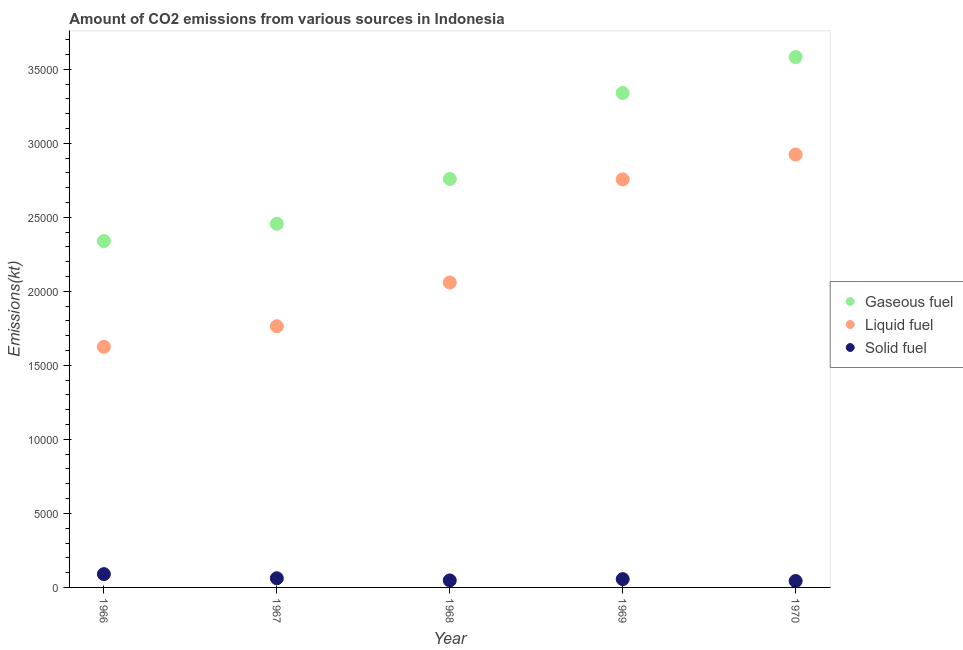How many different coloured dotlines are there?
Your answer should be very brief. 3. Is the number of dotlines equal to the number of legend labels?
Offer a terse response. Yes. What is the amount of co2 emissions from liquid fuel in 1969?
Make the answer very short. 2.76e+04. Across all years, what is the maximum amount of co2 emissions from solid fuel?
Offer a terse response. 898.41. Across all years, what is the minimum amount of co2 emissions from liquid fuel?
Your answer should be compact. 1.63e+04. In which year was the amount of co2 emissions from solid fuel maximum?
Ensure brevity in your answer.  1966. In which year was the amount of co2 emissions from gaseous fuel minimum?
Provide a succinct answer. 1966. What is the total amount of co2 emissions from liquid fuel in the graph?
Give a very brief answer. 1.11e+05. What is the difference between the amount of co2 emissions from solid fuel in 1969 and that in 1970?
Your answer should be compact. 128.34. What is the difference between the amount of co2 emissions from solid fuel in 1969 and the amount of co2 emissions from gaseous fuel in 1967?
Provide a short and direct response. -2.40e+04. What is the average amount of co2 emissions from gaseous fuel per year?
Provide a succinct answer. 2.90e+04. In the year 1967, what is the difference between the amount of co2 emissions from solid fuel and amount of co2 emissions from liquid fuel?
Your answer should be compact. -1.70e+04. In how many years, is the amount of co2 emissions from solid fuel greater than 4000 kt?
Keep it short and to the point. 0. What is the ratio of the amount of co2 emissions from solid fuel in 1967 to that in 1968?
Make the answer very short. 1.31. Is the amount of co2 emissions from gaseous fuel in 1966 less than that in 1970?
Your answer should be very brief. Yes. What is the difference between the highest and the second highest amount of co2 emissions from gaseous fuel?
Offer a very short reply. 2431.22. What is the difference between the highest and the lowest amount of co2 emissions from solid fuel?
Your answer should be compact. 465.71. Are the values on the major ticks of Y-axis written in scientific E-notation?
Ensure brevity in your answer.  No. Does the graph contain grids?
Keep it short and to the point. No. How many legend labels are there?
Keep it short and to the point. 3. How are the legend labels stacked?
Keep it short and to the point. Vertical. What is the title of the graph?
Ensure brevity in your answer.  Amount of CO2 emissions from various sources in Indonesia. Does "Coal" appear as one of the legend labels in the graph?
Your answer should be very brief. No. What is the label or title of the X-axis?
Keep it short and to the point. Year. What is the label or title of the Y-axis?
Ensure brevity in your answer.  Emissions(kt). What is the Emissions(kt) in Gaseous fuel in 1966?
Give a very brief answer. 2.34e+04. What is the Emissions(kt) of Liquid fuel in 1966?
Keep it short and to the point. 1.63e+04. What is the Emissions(kt) in Solid fuel in 1966?
Make the answer very short. 898.41. What is the Emissions(kt) in Gaseous fuel in 1967?
Your answer should be compact. 2.46e+04. What is the Emissions(kt) in Liquid fuel in 1967?
Offer a very short reply. 1.76e+04. What is the Emissions(kt) of Solid fuel in 1967?
Keep it short and to the point. 619.72. What is the Emissions(kt) of Gaseous fuel in 1968?
Keep it short and to the point. 2.76e+04. What is the Emissions(kt) in Liquid fuel in 1968?
Make the answer very short. 2.06e+04. What is the Emissions(kt) of Solid fuel in 1968?
Provide a short and direct response. 473.04. What is the Emissions(kt) of Gaseous fuel in 1969?
Your answer should be compact. 3.34e+04. What is the Emissions(kt) of Liquid fuel in 1969?
Your answer should be compact. 2.76e+04. What is the Emissions(kt) of Solid fuel in 1969?
Ensure brevity in your answer.  561.05. What is the Emissions(kt) in Gaseous fuel in 1970?
Give a very brief answer. 3.58e+04. What is the Emissions(kt) of Liquid fuel in 1970?
Your answer should be very brief. 2.92e+04. What is the Emissions(kt) in Solid fuel in 1970?
Provide a succinct answer. 432.71. Across all years, what is the maximum Emissions(kt) of Gaseous fuel?
Provide a short and direct response. 3.58e+04. Across all years, what is the maximum Emissions(kt) of Liquid fuel?
Offer a terse response. 2.92e+04. Across all years, what is the maximum Emissions(kt) of Solid fuel?
Keep it short and to the point. 898.41. Across all years, what is the minimum Emissions(kt) in Gaseous fuel?
Your answer should be very brief. 2.34e+04. Across all years, what is the minimum Emissions(kt) in Liquid fuel?
Make the answer very short. 1.63e+04. Across all years, what is the minimum Emissions(kt) in Solid fuel?
Make the answer very short. 432.71. What is the total Emissions(kt) of Gaseous fuel in the graph?
Make the answer very short. 1.45e+05. What is the total Emissions(kt) in Liquid fuel in the graph?
Offer a terse response. 1.11e+05. What is the total Emissions(kt) of Solid fuel in the graph?
Keep it short and to the point. 2984.94. What is the difference between the Emissions(kt) of Gaseous fuel in 1966 and that in 1967?
Your answer should be very brief. -1166.11. What is the difference between the Emissions(kt) in Liquid fuel in 1966 and that in 1967?
Offer a very short reply. -1386.13. What is the difference between the Emissions(kt) in Solid fuel in 1966 and that in 1967?
Provide a succinct answer. 278.69. What is the difference between the Emissions(kt) of Gaseous fuel in 1966 and that in 1968?
Your response must be concise. -4191.38. What is the difference between the Emissions(kt) in Liquid fuel in 1966 and that in 1968?
Your response must be concise. -4341.73. What is the difference between the Emissions(kt) of Solid fuel in 1966 and that in 1968?
Offer a terse response. 425.37. What is the difference between the Emissions(kt) of Gaseous fuel in 1966 and that in 1969?
Provide a succinct answer. -9996.24. What is the difference between the Emissions(kt) in Liquid fuel in 1966 and that in 1969?
Give a very brief answer. -1.13e+04. What is the difference between the Emissions(kt) of Solid fuel in 1966 and that in 1969?
Keep it short and to the point. 337.36. What is the difference between the Emissions(kt) in Gaseous fuel in 1966 and that in 1970?
Provide a succinct answer. -1.24e+04. What is the difference between the Emissions(kt) in Liquid fuel in 1966 and that in 1970?
Provide a short and direct response. -1.30e+04. What is the difference between the Emissions(kt) of Solid fuel in 1966 and that in 1970?
Your answer should be compact. 465.71. What is the difference between the Emissions(kt) of Gaseous fuel in 1967 and that in 1968?
Keep it short and to the point. -3025.28. What is the difference between the Emissions(kt) of Liquid fuel in 1967 and that in 1968?
Make the answer very short. -2955.6. What is the difference between the Emissions(kt) of Solid fuel in 1967 and that in 1968?
Your answer should be compact. 146.68. What is the difference between the Emissions(kt) of Gaseous fuel in 1967 and that in 1969?
Your answer should be very brief. -8830.14. What is the difference between the Emissions(kt) of Liquid fuel in 1967 and that in 1969?
Your response must be concise. -9919.24. What is the difference between the Emissions(kt) of Solid fuel in 1967 and that in 1969?
Offer a very short reply. 58.67. What is the difference between the Emissions(kt) in Gaseous fuel in 1967 and that in 1970?
Provide a short and direct response. -1.13e+04. What is the difference between the Emissions(kt) in Liquid fuel in 1967 and that in 1970?
Ensure brevity in your answer.  -1.16e+04. What is the difference between the Emissions(kt) in Solid fuel in 1967 and that in 1970?
Provide a short and direct response. 187.02. What is the difference between the Emissions(kt) in Gaseous fuel in 1968 and that in 1969?
Your answer should be very brief. -5804.86. What is the difference between the Emissions(kt) in Liquid fuel in 1968 and that in 1969?
Give a very brief answer. -6963.63. What is the difference between the Emissions(kt) of Solid fuel in 1968 and that in 1969?
Provide a succinct answer. -88.01. What is the difference between the Emissions(kt) in Gaseous fuel in 1968 and that in 1970?
Give a very brief answer. -8236.08. What is the difference between the Emissions(kt) in Liquid fuel in 1968 and that in 1970?
Provide a short and direct response. -8643.12. What is the difference between the Emissions(kt) in Solid fuel in 1968 and that in 1970?
Offer a terse response. 40.34. What is the difference between the Emissions(kt) of Gaseous fuel in 1969 and that in 1970?
Your answer should be very brief. -2431.22. What is the difference between the Emissions(kt) in Liquid fuel in 1969 and that in 1970?
Ensure brevity in your answer.  -1679.49. What is the difference between the Emissions(kt) of Solid fuel in 1969 and that in 1970?
Provide a succinct answer. 128.34. What is the difference between the Emissions(kt) in Gaseous fuel in 1966 and the Emissions(kt) in Liquid fuel in 1967?
Your response must be concise. 5757.19. What is the difference between the Emissions(kt) in Gaseous fuel in 1966 and the Emissions(kt) in Solid fuel in 1967?
Provide a short and direct response. 2.28e+04. What is the difference between the Emissions(kt) in Liquid fuel in 1966 and the Emissions(kt) in Solid fuel in 1967?
Ensure brevity in your answer.  1.56e+04. What is the difference between the Emissions(kt) of Gaseous fuel in 1966 and the Emissions(kt) of Liquid fuel in 1968?
Provide a succinct answer. 2801.59. What is the difference between the Emissions(kt) of Gaseous fuel in 1966 and the Emissions(kt) of Solid fuel in 1968?
Give a very brief answer. 2.29e+04. What is the difference between the Emissions(kt) of Liquid fuel in 1966 and the Emissions(kt) of Solid fuel in 1968?
Ensure brevity in your answer.  1.58e+04. What is the difference between the Emissions(kt) in Gaseous fuel in 1966 and the Emissions(kt) in Liquid fuel in 1969?
Your response must be concise. -4162.05. What is the difference between the Emissions(kt) of Gaseous fuel in 1966 and the Emissions(kt) of Solid fuel in 1969?
Make the answer very short. 2.28e+04. What is the difference between the Emissions(kt) of Liquid fuel in 1966 and the Emissions(kt) of Solid fuel in 1969?
Make the answer very short. 1.57e+04. What is the difference between the Emissions(kt) of Gaseous fuel in 1966 and the Emissions(kt) of Liquid fuel in 1970?
Make the answer very short. -5841.53. What is the difference between the Emissions(kt) of Gaseous fuel in 1966 and the Emissions(kt) of Solid fuel in 1970?
Your response must be concise. 2.30e+04. What is the difference between the Emissions(kt) in Liquid fuel in 1966 and the Emissions(kt) in Solid fuel in 1970?
Your answer should be compact. 1.58e+04. What is the difference between the Emissions(kt) of Gaseous fuel in 1967 and the Emissions(kt) of Liquid fuel in 1968?
Ensure brevity in your answer.  3967.69. What is the difference between the Emissions(kt) in Gaseous fuel in 1967 and the Emissions(kt) in Solid fuel in 1968?
Give a very brief answer. 2.41e+04. What is the difference between the Emissions(kt) of Liquid fuel in 1967 and the Emissions(kt) of Solid fuel in 1968?
Offer a terse response. 1.72e+04. What is the difference between the Emissions(kt) in Gaseous fuel in 1967 and the Emissions(kt) in Liquid fuel in 1969?
Ensure brevity in your answer.  -2995.94. What is the difference between the Emissions(kt) in Gaseous fuel in 1967 and the Emissions(kt) in Solid fuel in 1969?
Your answer should be very brief. 2.40e+04. What is the difference between the Emissions(kt) of Liquid fuel in 1967 and the Emissions(kt) of Solid fuel in 1969?
Make the answer very short. 1.71e+04. What is the difference between the Emissions(kt) of Gaseous fuel in 1967 and the Emissions(kt) of Liquid fuel in 1970?
Provide a short and direct response. -4675.43. What is the difference between the Emissions(kt) in Gaseous fuel in 1967 and the Emissions(kt) in Solid fuel in 1970?
Ensure brevity in your answer.  2.41e+04. What is the difference between the Emissions(kt) in Liquid fuel in 1967 and the Emissions(kt) in Solid fuel in 1970?
Your answer should be compact. 1.72e+04. What is the difference between the Emissions(kt) in Gaseous fuel in 1968 and the Emissions(kt) in Liquid fuel in 1969?
Give a very brief answer. 29.34. What is the difference between the Emissions(kt) in Gaseous fuel in 1968 and the Emissions(kt) in Solid fuel in 1969?
Make the answer very short. 2.70e+04. What is the difference between the Emissions(kt) of Liquid fuel in 1968 and the Emissions(kt) of Solid fuel in 1969?
Provide a short and direct response. 2.00e+04. What is the difference between the Emissions(kt) in Gaseous fuel in 1968 and the Emissions(kt) in Liquid fuel in 1970?
Keep it short and to the point. -1650.15. What is the difference between the Emissions(kt) in Gaseous fuel in 1968 and the Emissions(kt) in Solid fuel in 1970?
Your answer should be very brief. 2.72e+04. What is the difference between the Emissions(kt) in Liquid fuel in 1968 and the Emissions(kt) in Solid fuel in 1970?
Offer a very short reply. 2.02e+04. What is the difference between the Emissions(kt) in Gaseous fuel in 1969 and the Emissions(kt) in Liquid fuel in 1970?
Offer a terse response. 4154.71. What is the difference between the Emissions(kt) in Gaseous fuel in 1969 and the Emissions(kt) in Solid fuel in 1970?
Provide a succinct answer. 3.30e+04. What is the difference between the Emissions(kt) of Liquid fuel in 1969 and the Emissions(kt) of Solid fuel in 1970?
Your answer should be compact. 2.71e+04. What is the average Emissions(kt) of Gaseous fuel per year?
Provide a succinct answer. 2.90e+04. What is the average Emissions(kt) in Liquid fuel per year?
Your answer should be compact. 2.23e+04. What is the average Emissions(kt) of Solid fuel per year?
Make the answer very short. 596.99. In the year 1966, what is the difference between the Emissions(kt) in Gaseous fuel and Emissions(kt) in Liquid fuel?
Your answer should be compact. 7143.32. In the year 1966, what is the difference between the Emissions(kt) in Gaseous fuel and Emissions(kt) in Solid fuel?
Provide a short and direct response. 2.25e+04. In the year 1966, what is the difference between the Emissions(kt) in Liquid fuel and Emissions(kt) in Solid fuel?
Your answer should be very brief. 1.54e+04. In the year 1967, what is the difference between the Emissions(kt) in Gaseous fuel and Emissions(kt) in Liquid fuel?
Your answer should be compact. 6923.3. In the year 1967, what is the difference between the Emissions(kt) in Gaseous fuel and Emissions(kt) in Solid fuel?
Offer a terse response. 2.39e+04. In the year 1967, what is the difference between the Emissions(kt) in Liquid fuel and Emissions(kt) in Solid fuel?
Make the answer very short. 1.70e+04. In the year 1968, what is the difference between the Emissions(kt) of Gaseous fuel and Emissions(kt) of Liquid fuel?
Give a very brief answer. 6992.97. In the year 1968, what is the difference between the Emissions(kt) of Gaseous fuel and Emissions(kt) of Solid fuel?
Provide a succinct answer. 2.71e+04. In the year 1968, what is the difference between the Emissions(kt) of Liquid fuel and Emissions(kt) of Solid fuel?
Make the answer very short. 2.01e+04. In the year 1969, what is the difference between the Emissions(kt) of Gaseous fuel and Emissions(kt) of Liquid fuel?
Provide a short and direct response. 5834.2. In the year 1969, what is the difference between the Emissions(kt) of Gaseous fuel and Emissions(kt) of Solid fuel?
Make the answer very short. 3.28e+04. In the year 1969, what is the difference between the Emissions(kt) of Liquid fuel and Emissions(kt) of Solid fuel?
Keep it short and to the point. 2.70e+04. In the year 1970, what is the difference between the Emissions(kt) in Gaseous fuel and Emissions(kt) in Liquid fuel?
Make the answer very short. 6585.93. In the year 1970, what is the difference between the Emissions(kt) of Gaseous fuel and Emissions(kt) of Solid fuel?
Offer a very short reply. 3.54e+04. In the year 1970, what is the difference between the Emissions(kt) in Liquid fuel and Emissions(kt) in Solid fuel?
Give a very brief answer. 2.88e+04. What is the ratio of the Emissions(kt) in Gaseous fuel in 1966 to that in 1967?
Make the answer very short. 0.95. What is the ratio of the Emissions(kt) in Liquid fuel in 1966 to that in 1967?
Provide a short and direct response. 0.92. What is the ratio of the Emissions(kt) of Solid fuel in 1966 to that in 1967?
Offer a very short reply. 1.45. What is the ratio of the Emissions(kt) of Gaseous fuel in 1966 to that in 1968?
Offer a terse response. 0.85. What is the ratio of the Emissions(kt) of Liquid fuel in 1966 to that in 1968?
Ensure brevity in your answer.  0.79. What is the ratio of the Emissions(kt) in Solid fuel in 1966 to that in 1968?
Your answer should be very brief. 1.9. What is the ratio of the Emissions(kt) of Gaseous fuel in 1966 to that in 1969?
Provide a short and direct response. 0.7. What is the ratio of the Emissions(kt) in Liquid fuel in 1966 to that in 1969?
Ensure brevity in your answer.  0.59. What is the ratio of the Emissions(kt) in Solid fuel in 1966 to that in 1969?
Give a very brief answer. 1.6. What is the ratio of the Emissions(kt) in Gaseous fuel in 1966 to that in 1970?
Your response must be concise. 0.65. What is the ratio of the Emissions(kt) in Liquid fuel in 1966 to that in 1970?
Your answer should be very brief. 0.56. What is the ratio of the Emissions(kt) in Solid fuel in 1966 to that in 1970?
Your answer should be compact. 2.08. What is the ratio of the Emissions(kt) of Gaseous fuel in 1967 to that in 1968?
Your answer should be compact. 0.89. What is the ratio of the Emissions(kt) of Liquid fuel in 1967 to that in 1968?
Keep it short and to the point. 0.86. What is the ratio of the Emissions(kt) of Solid fuel in 1967 to that in 1968?
Make the answer very short. 1.31. What is the ratio of the Emissions(kt) in Gaseous fuel in 1967 to that in 1969?
Provide a succinct answer. 0.74. What is the ratio of the Emissions(kt) of Liquid fuel in 1967 to that in 1969?
Your answer should be compact. 0.64. What is the ratio of the Emissions(kt) of Solid fuel in 1967 to that in 1969?
Provide a short and direct response. 1.1. What is the ratio of the Emissions(kt) in Gaseous fuel in 1967 to that in 1970?
Provide a succinct answer. 0.69. What is the ratio of the Emissions(kt) in Liquid fuel in 1967 to that in 1970?
Offer a very short reply. 0.6. What is the ratio of the Emissions(kt) of Solid fuel in 1967 to that in 1970?
Offer a very short reply. 1.43. What is the ratio of the Emissions(kt) in Gaseous fuel in 1968 to that in 1969?
Give a very brief answer. 0.83. What is the ratio of the Emissions(kt) of Liquid fuel in 1968 to that in 1969?
Make the answer very short. 0.75. What is the ratio of the Emissions(kt) of Solid fuel in 1968 to that in 1969?
Your answer should be compact. 0.84. What is the ratio of the Emissions(kt) in Gaseous fuel in 1968 to that in 1970?
Give a very brief answer. 0.77. What is the ratio of the Emissions(kt) of Liquid fuel in 1968 to that in 1970?
Provide a short and direct response. 0.7. What is the ratio of the Emissions(kt) in Solid fuel in 1968 to that in 1970?
Offer a terse response. 1.09. What is the ratio of the Emissions(kt) of Gaseous fuel in 1969 to that in 1970?
Keep it short and to the point. 0.93. What is the ratio of the Emissions(kt) of Liquid fuel in 1969 to that in 1970?
Make the answer very short. 0.94. What is the ratio of the Emissions(kt) of Solid fuel in 1969 to that in 1970?
Keep it short and to the point. 1.3. What is the difference between the highest and the second highest Emissions(kt) in Gaseous fuel?
Offer a very short reply. 2431.22. What is the difference between the highest and the second highest Emissions(kt) in Liquid fuel?
Your answer should be very brief. 1679.49. What is the difference between the highest and the second highest Emissions(kt) of Solid fuel?
Ensure brevity in your answer.  278.69. What is the difference between the highest and the lowest Emissions(kt) in Gaseous fuel?
Make the answer very short. 1.24e+04. What is the difference between the highest and the lowest Emissions(kt) of Liquid fuel?
Your response must be concise. 1.30e+04. What is the difference between the highest and the lowest Emissions(kt) of Solid fuel?
Keep it short and to the point. 465.71. 